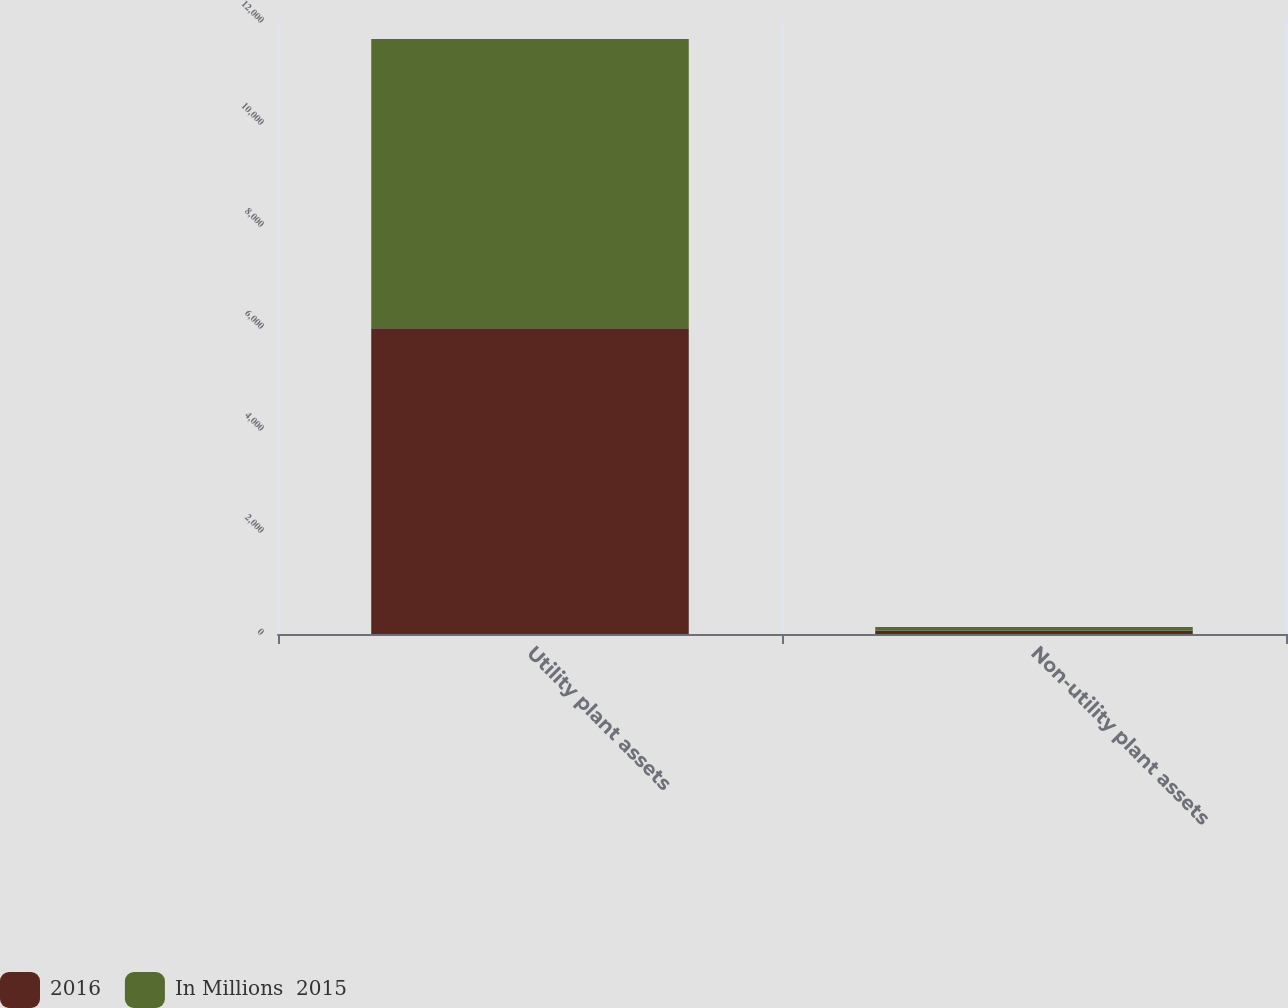<chart> <loc_0><loc_0><loc_500><loc_500><stacked_bar_chart><ecel><fcel>Utility plant assets<fcel>Non-utility plant assets<nl><fcel>2016<fcel>5993<fcel>63<nl><fcel>In Millions  2015<fcel>5674<fcel>73<nl></chart> 